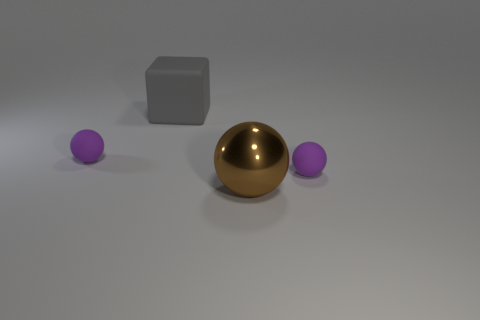What is the texture of the surfaces visible in the image? The textures in the image suggest a smooth finish on all the objects. The floor also displays a smooth surface with a slight reflection, indicating it might be a polished material. 